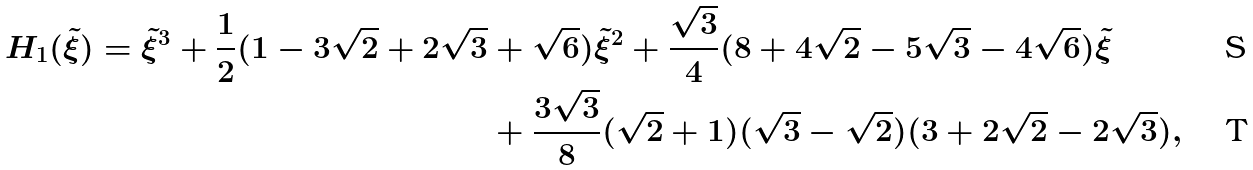<formula> <loc_0><loc_0><loc_500><loc_500>H _ { 1 } ( \tilde { \xi } ) = \tilde { \xi } ^ { 3 } + \frac { 1 } { 2 } ( 1 - 3 \sqrt { 2 } + 2 \sqrt { 3 } & + \sqrt { 6 } ) \tilde { \xi } ^ { 2 } + \frac { \sqrt { 3 } } { 4 } ( 8 + 4 \sqrt { 2 } - 5 \sqrt { 3 } - 4 \sqrt { 6 } ) \tilde { \xi } \\ & + \frac { 3 \sqrt { 3 } } { 8 } ( \sqrt { 2 } + 1 ) ( \sqrt { 3 } - \sqrt { 2 } ) ( 3 + 2 \sqrt { 2 } - 2 \sqrt { 3 } ) ,</formula> 